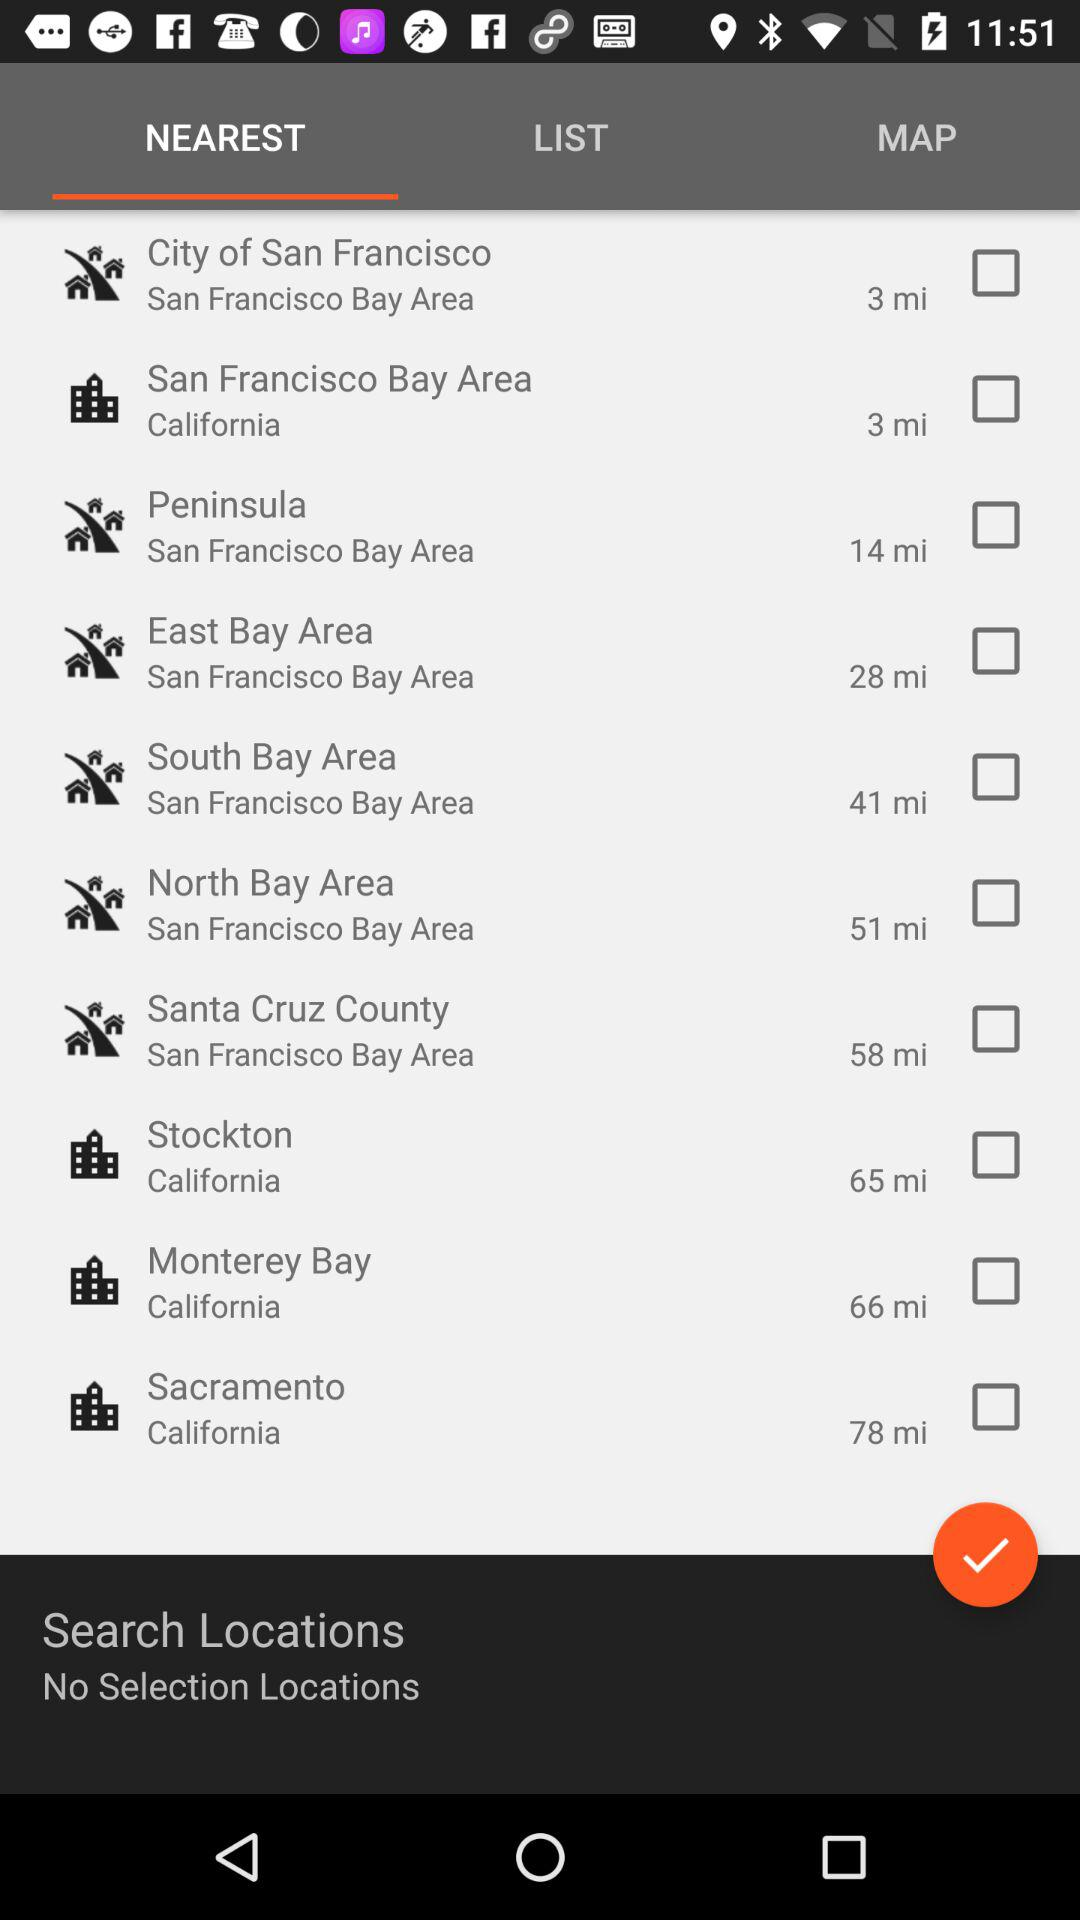Which tab is selected? The selected tab is "NEAREST". 